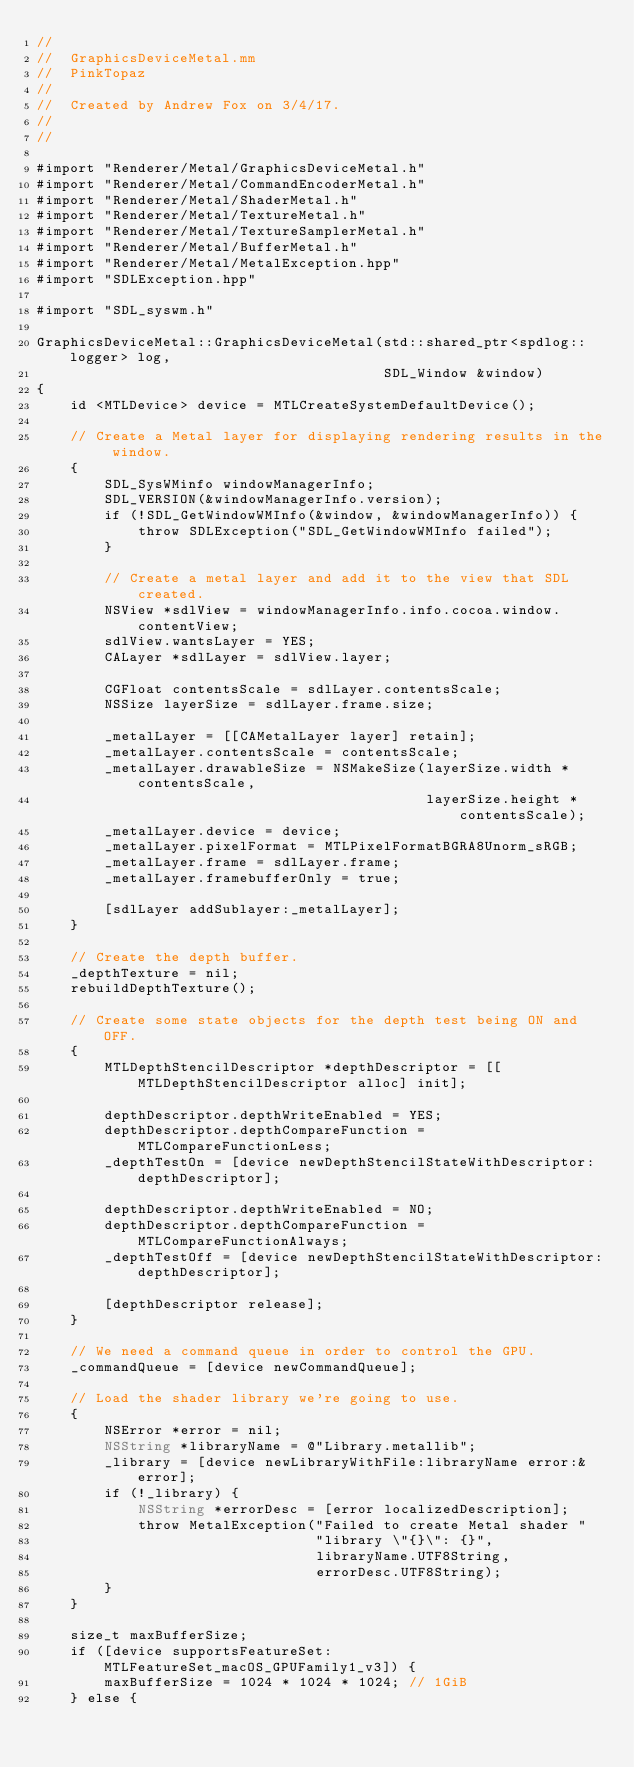Convert code to text. <code><loc_0><loc_0><loc_500><loc_500><_ObjectiveC_>//
//  GraphicsDeviceMetal.mm
//  PinkTopaz
//
//  Created by Andrew Fox on 3/4/17.
//
//

#import "Renderer/Metal/GraphicsDeviceMetal.h"
#import "Renderer/Metal/CommandEncoderMetal.h"
#import "Renderer/Metal/ShaderMetal.h"
#import "Renderer/Metal/TextureMetal.h"
#import "Renderer/Metal/TextureSamplerMetal.h"
#import "Renderer/Metal/BufferMetal.h"
#import "Renderer/Metal/MetalException.hpp"
#import "SDLException.hpp"

#import "SDL_syswm.h"

GraphicsDeviceMetal::GraphicsDeviceMetal(std::shared_ptr<spdlog::logger> log,
                                         SDL_Window &window)
{
    id <MTLDevice> device = MTLCreateSystemDefaultDevice();
    
    // Create a Metal layer for displaying rendering results in the window.
    {
        SDL_SysWMinfo windowManagerInfo;
        SDL_VERSION(&windowManagerInfo.version);
        if (!SDL_GetWindowWMInfo(&window, &windowManagerInfo)) {
            throw SDLException("SDL_GetWindowWMInfo failed");
        }
        
        // Create a metal layer and add it to the view that SDL created.
        NSView *sdlView = windowManagerInfo.info.cocoa.window.contentView;
        sdlView.wantsLayer = YES;
        CALayer *sdlLayer = sdlView.layer;
        
        CGFloat contentsScale = sdlLayer.contentsScale;
        NSSize layerSize = sdlLayer.frame.size;
        
        _metalLayer = [[CAMetalLayer layer] retain];
        _metalLayer.contentsScale = contentsScale;
        _metalLayer.drawableSize = NSMakeSize(layerSize.width * contentsScale,
                                              layerSize.height * contentsScale);
        _metalLayer.device = device;
        _metalLayer.pixelFormat = MTLPixelFormatBGRA8Unorm_sRGB;
        _metalLayer.frame = sdlLayer.frame;
        _metalLayer.framebufferOnly = true;
        
        [sdlLayer addSublayer:_metalLayer];
    }
    
    // Create the depth buffer.
    _depthTexture = nil;
    rebuildDepthTexture();
    
    // Create some state objects for the depth test being ON and OFF.
    {
        MTLDepthStencilDescriptor *depthDescriptor = [[MTLDepthStencilDescriptor alloc] init];
        
        depthDescriptor.depthWriteEnabled = YES;
        depthDescriptor.depthCompareFunction = MTLCompareFunctionLess;
        _depthTestOn = [device newDepthStencilStateWithDescriptor:depthDescriptor];
        
        depthDescriptor.depthWriteEnabled = NO;
        depthDescriptor.depthCompareFunction = MTLCompareFunctionAlways;
        _depthTestOff = [device newDepthStencilStateWithDescriptor:depthDescriptor];
        
        [depthDescriptor release];
    }
    
    // We need a command queue in order to control the GPU.
    _commandQueue = [device newCommandQueue];
    
    // Load the shader library we're going to use.
    {
        NSError *error = nil;
        NSString *libraryName = @"Library.metallib";
        _library = [device newLibraryWithFile:libraryName error:&error];
        if (!_library) {
            NSString *errorDesc = [error localizedDescription];
            throw MetalException("Failed to create Metal shader "
                                 "library \"{}\": {}",
                                 libraryName.UTF8String,
                                 errorDesc.UTF8String);
        }
    }
    
    size_t maxBufferSize;
    if ([device supportsFeatureSet:MTLFeatureSet_macOS_GPUFamily1_v3]) {
        maxBufferSize = 1024 * 1024 * 1024; // 1GiB
    } else {</code> 